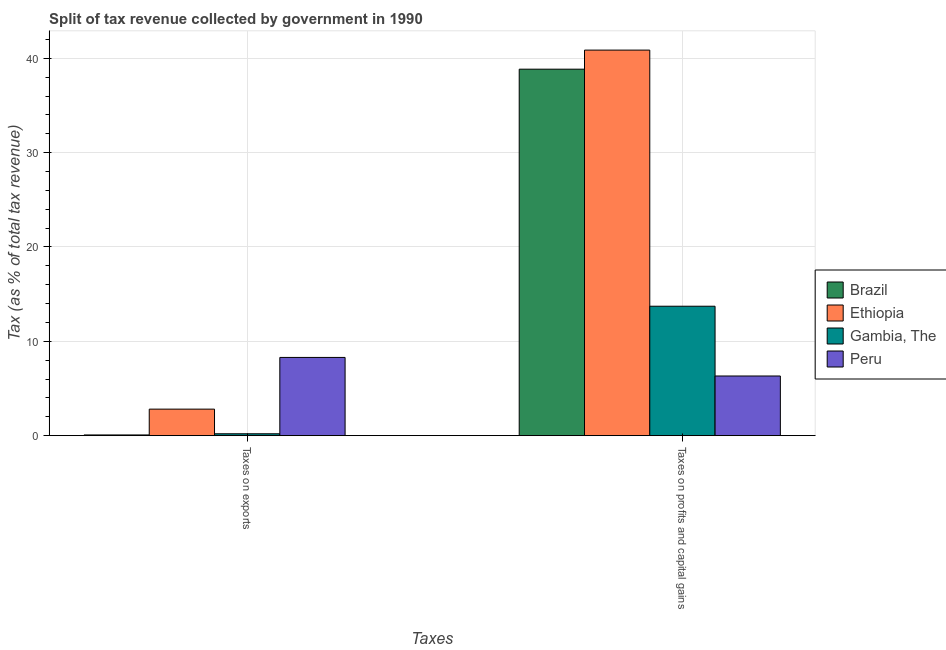How many bars are there on the 2nd tick from the left?
Provide a succinct answer. 4. What is the label of the 2nd group of bars from the left?
Provide a succinct answer. Taxes on profits and capital gains. What is the percentage of revenue obtained from taxes on exports in Ethiopia?
Your answer should be very brief. 2.81. Across all countries, what is the maximum percentage of revenue obtained from taxes on profits and capital gains?
Your answer should be compact. 40.87. Across all countries, what is the minimum percentage of revenue obtained from taxes on exports?
Make the answer very short. 0.07. In which country was the percentage of revenue obtained from taxes on profits and capital gains maximum?
Give a very brief answer. Ethiopia. In which country was the percentage of revenue obtained from taxes on exports minimum?
Your answer should be very brief. Brazil. What is the total percentage of revenue obtained from taxes on profits and capital gains in the graph?
Provide a succinct answer. 99.76. What is the difference between the percentage of revenue obtained from taxes on exports in Brazil and that in Ethiopia?
Provide a short and direct response. -2.74. What is the difference between the percentage of revenue obtained from taxes on profits and capital gains in Brazil and the percentage of revenue obtained from taxes on exports in Ethiopia?
Your answer should be very brief. 36.04. What is the average percentage of revenue obtained from taxes on exports per country?
Keep it short and to the point. 2.84. What is the difference between the percentage of revenue obtained from taxes on profits and capital gains and percentage of revenue obtained from taxes on exports in Ethiopia?
Your answer should be compact. 38.06. In how many countries, is the percentage of revenue obtained from taxes on profits and capital gains greater than 22 %?
Ensure brevity in your answer.  2. What is the ratio of the percentage of revenue obtained from taxes on exports in Brazil to that in Ethiopia?
Offer a terse response. 0.03. In how many countries, is the percentage of revenue obtained from taxes on profits and capital gains greater than the average percentage of revenue obtained from taxes on profits and capital gains taken over all countries?
Keep it short and to the point. 2. What does the 3rd bar from the left in Taxes on exports represents?
Offer a terse response. Gambia, The. What does the 1st bar from the right in Taxes on exports represents?
Your response must be concise. Peru. Are all the bars in the graph horizontal?
Ensure brevity in your answer.  No. Where does the legend appear in the graph?
Your response must be concise. Center right. How many legend labels are there?
Make the answer very short. 4. What is the title of the graph?
Keep it short and to the point. Split of tax revenue collected by government in 1990. Does "Hungary" appear as one of the legend labels in the graph?
Your answer should be compact. No. What is the label or title of the X-axis?
Offer a terse response. Taxes. What is the label or title of the Y-axis?
Make the answer very short. Tax (as % of total tax revenue). What is the Tax (as % of total tax revenue) of Brazil in Taxes on exports?
Your response must be concise. 0.07. What is the Tax (as % of total tax revenue) of Ethiopia in Taxes on exports?
Make the answer very short. 2.81. What is the Tax (as % of total tax revenue) in Gambia, The in Taxes on exports?
Keep it short and to the point. 0.2. What is the Tax (as % of total tax revenue) in Peru in Taxes on exports?
Your answer should be compact. 8.29. What is the Tax (as % of total tax revenue) in Brazil in Taxes on profits and capital gains?
Your response must be concise. 38.85. What is the Tax (as % of total tax revenue) of Ethiopia in Taxes on profits and capital gains?
Provide a succinct answer. 40.87. What is the Tax (as % of total tax revenue) in Gambia, The in Taxes on profits and capital gains?
Your response must be concise. 13.72. What is the Tax (as % of total tax revenue) of Peru in Taxes on profits and capital gains?
Provide a succinct answer. 6.32. Across all Taxes, what is the maximum Tax (as % of total tax revenue) in Brazil?
Make the answer very short. 38.85. Across all Taxes, what is the maximum Tax (as % of total tax revenue) in Ethiopia?
Offer a terse response. 40.87. Across all Taxes, what is the maximum Tax (as % of total tax revenue) in Gambia, The?
Your answer should be very brief. 13.72. Across all Taxes, what is the maximum Tax (as % of total tax revenue) of Peru?
Your answer should be very brief. 8.29. Across all Taxes, what is the minimum Tax (as % of total tax revenue) of Brazil?
Make the answer very short. 0.07. Across all Taxes, what is the minimum Tax (as % of total tax revenue) of Ethiopia?
Ensure brevity in your answer.  2.81. Across all Taxes, what is the minimum Tax (as % of total tax revenue) of Gambia, The?
Provide a succinct answer. 0.2. Across all Taxes, what is the minimum Tax (as % of total tax revenue) in Peru?
Offer a very short reply. 6.32. What is the total Tax (as % of total tax revenue) of Brazil in the graph?
Offer a terse response. 38.92. What is the total Tax (as % of total tax revenue) in Ethiopia in the graph?
Give a very brief answer. 43.68. What is the total Tax (as % of total tax revenue) of Gambia, The in the graph?
Offer a terse response. 13.92. What is the total Tax (as % of total tax revenue) of Peru in the graph?
Provide a short and direct response. 14.61. What is the difference between the Tax (as % of total tax revenue) in Brazil in Taxes on exports and that in Taxes on profits and capital gains?
Make the answer very short. -38.78. What is the difference between the Tax (as % of total tax revenue) of Ethiopia in Taxes on exports and that in Taxes on profits and capital gains?
Ensure brevity in your answer.  -38.06. What is the difference between the Tax (as % of total tax revenue) of Gambia, The in Taxes on exports and that in Taxes on profits and capital gains?
Give a very brief answer. -13.52. What is the difference between the Tax (as % of total tax revenue) of Peru in Taxes on exports and that in Taxes on profits and capital gains?
Your response must be concise. 1.97. What is the difference between the Tax (as % of total tax revenue) in Brazil in Taxes on exports and the Tax (as % of total tax revenue) in Ethiopia in Taxes on profits and capital gains?
Make the answer very short. -40.8. What is the difference between the Tax (as % of total tax revenue) of Brazil in Taxes on exports and the Tax (as % of total tax revenue) of Gambia, The in Taxes on profits and capital gains?
Make the answer very short. -13.65. What is the difference between the Tax (as % of total tax revenue) in Brazil in Taxes on exports and the Tax (as % of total tax revenue) in Peru in Taxes on profits and capital gains?
Give a very brief answer. -6.25. What is the difference between the Tax (as % of total tax revenue) of Ethiopia in Taxes on exports and the Tax (as % of total tax revenue) of Gambia, The in Taxes on profits and capital gains?
Offer a terse response. -10.91. What is the difference between the Tax (as % of total tax revenue) of Ethiopia in Taxes on exports and the Tax (as % of total tax revenue) of Peru in Taxes on profits and capital gains?
Your answer should be very brief. -3.51. What is the difference between the Tax (as % of total tax revenue) in Gambia, The in Taxes on exports and the Tax (as % of total tax revenue) in Peru in Taxes on profits and capital gains?
Ensure brevity in your answer.  -6.13. What is the average Tax (as % of total tax revenue) of Brazil per Taxes?
Your answer should be very brief. 19.46. What is the average Tax (as % of total tax revenue) of Ethiopia per Taxes?
Offer a very short reply. 21.84. What is the average Tax (as % of total tax revenue) in Gambia, The per Taxes?
Your response must be concise. 6.96. What is the average Tax (as % of total tax revenue) of Peru per Taxes?
Give a very brief answer. 7.31. What is the difference between the Tax (as % of total tax revenue) in Brazil and Tax (as % of total tax revenue) in Ethiopia in Taxes on exports?
Give a very brief answer. -2.74. What is the difference between the Tax (as % of total tax revenue) in Brazil and Tax (as % of total tax revenue) in Gambia, The in Taxes on exports?
Offer a very short reply. -0.12. What is the difference between the Tax (as % of total tax revenue) in Brazil and Tax (as % of total tax revenue) in Peru in Taxes on exports?
Your answer should be compact. -8.22. What is the difference between the Tax (as % of total tax revenue) in Ethiopia and Tax (as % of total tax revenue) in Gambia, The in Taxes on exports?
Your response must be concise. 2.61. What is the difference between the Tax (as % of total tax revenue) of Ethiopia and Tax (as % of total tax revenue) of Peru in Taxes on exports?
Your answer should be compact. -5.48. What is the difference between the Tax (as % of total tax revenue) in Gambia, The and Tax (as % of total tax revenue) in Peru in Taxes on exports?
Your answer should be compact. -8.09. What is the difference between the Tax (as % of total tax revenue) of Brazil and Tax (as % of total tax revenue) of Ethiopia in Taxes on profits and capital gains?
Your response must be concise. -2.02. What is the difference between the Tax (as % of total tax revenue) in Brazil and Tax (as % of total tax revenue) in Gambia, The in Taxes on profits and capital gains?
Your answer should be compact. 25.13. What is the difference between the Tax (as % of total tax revenue) in Brazil and Tax (as % of total tax revenue) in Peru in Taxes on profits and capital gains?
Your answer should be very brief. 32.53. What is the difference between the Tax (as % of total tax revenue) of Ethiopia and Tax (as % of total tax revenue) of Gambia, The in Taxes on profits and capital gains?
Your response must be concise. 27.15. What is the difference between the Tax (as % of total tax revenue) of Ethiopia and Tax (as % of total tax revenue) of Peru in Taxes on profits and capital gains?
Make the answer very short. 34.55. What is the difference between the Tax (as % of total tax revenue) of Gambia, The and Tax (as % of total tax revenue) of Peru in Taxes on profits and capital gains?
Provide a succinct answer. 7.4. What is the ratio of the Tax (as % of total tax revenue) in Brazil in Taxes on exports to that in Taxes on profits and capital gains?
Ensure brevity in your answer.  0. What is the ratio of the Tax (as % of total tax revenue) in Ethiopia in Taxes on exports to that in Taxes on profits and capital gains?
Offer a terse response. 0.07. What is the ratio of the Tax (as % of total tax revenue) in Gambia, The in Taxes on exports to that in Taxes on profits and capital gains?
Your answer should be very brief. 0.01. What is the ratio of the Tax (as % of total tax revenue) in Peru in Taxes on exports to that in Taxes on profits and capital gains?
Your answer should be very brief. 1.31. What is the difference between the highest and the second highest Tax (as % of total tax revenue) of Brazil?
Provide a succinct answer. 38.78. What is the difference between the highest and the second highest Tax (as % of total tax revenue) of Ethiopia?
Provide a short and direct response. 38.06. What is the difference between the highest and the second highest Tax (as % of total tax revenue) in Gambia, The?
Provide a short and direct response. 13.52. What is the difference between the highest and the second highest Tax (as % of total tax revenue) in Peru?
Give a very brief answer. 1.97. What is the difference between the highest and the lowest Tax (as % of total tax revenue) of Brazil?
Offer a terse response. 38.78. What is the difference between the highest and the lowest Tax (as % of total tax revenue) of Ethiopia?
Your answer should be very brief. 38.06. What is the difference between the highest and the lowest Tax (as % of total tax revenue) of Gambia, The?
Your answer should be compact. 13.52. What is the difference between the highest and the lowest Tax (as % of total tax revenue) of Peru?
Provide a short and direct response. 1.97. 